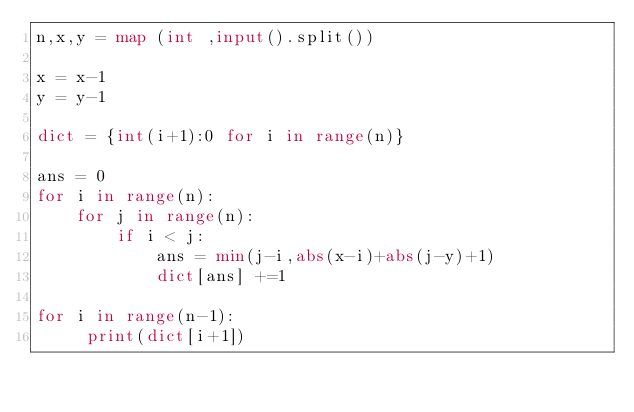<code> <loc_0><loc_0><loc_500><loc_500><_Python_>n,x,y = map (int ,input().split())

x = x-1
y = y-1

dict = {int(i+1):0 for i in range(n)}

ans = 0
for i in range(n):
    for j in range(n):
        if i < j:
            ans = min(j-i,abs(x-i)+abs(j-y)+1)
            dict[ans] +=1
            
for i in range(n-1):
     print(dict[i+1])</code> 